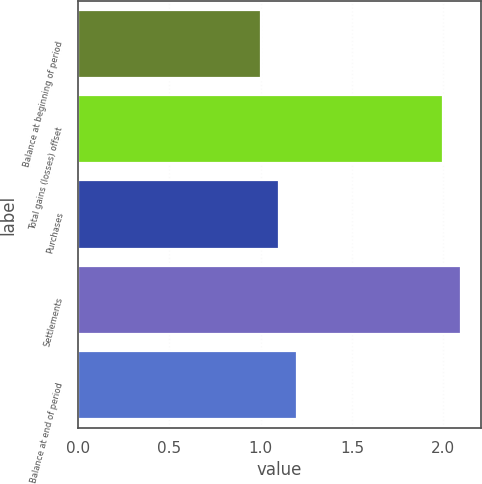<chart> <loc_0><loc_0><loc_500><loc_500><bar_chart><fcel>Balance at beginning of period<fcel>Total gains (losses) offset<fcel>Purchases<fcel>Settlements<fcel>Balance at end of period<nl><fcel>1<fcel>2<fcel>1.1<fcel>2.1<fcel>1.2<nl></chart> 